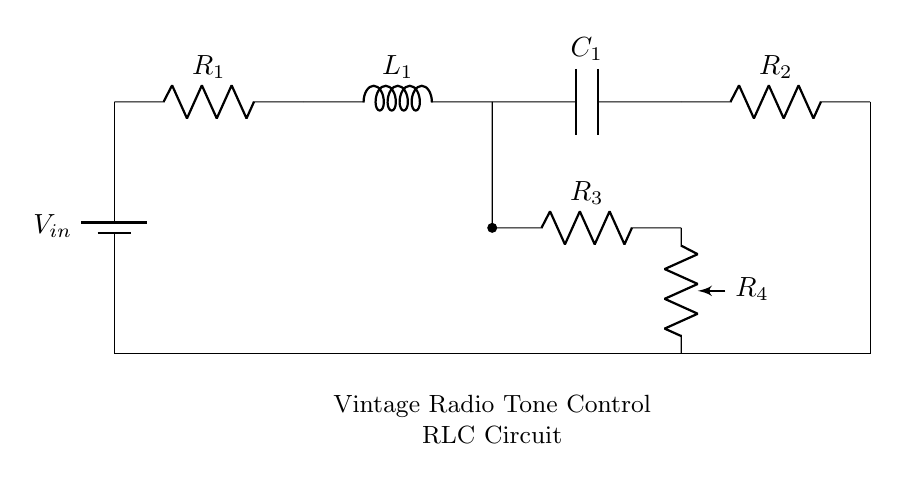What is the input voltage of this circuit? The input voltage is indicated by the battery symbol labeled as V_in in the circuit diagram. It provides the power source to the circuit.
Answer: V_in What type of circuit components are used in this diagram? The circuit consists of resistors, an inductor, and a capacitor, which are essential elements of RLC circuits. This is identifiable through the symbols used in the diagram.
Answer: Resistors, inductor, capacitor What is the resistance of R_1? The resistance value of R_1 is not specified in the diagram, but it is depicted as one of the components connected directly to the voltage source. Therefore, it plays a role in controlling current and voltage in the circuit.
Answer: Not specified How many resistors are present in this circuit? By counting the resistor symbols in the circuit, we find four resistors: R_1, R_2, R_3, and R_4. Thus, the total number of resistors is four.
Answer: Four What happens when the potentiometer R_4 is adjusted? Adjusting the potentiometer R_4 changes the resistance in that branch, affecting the current flow and hence the voltage across the connected components. This adjusts the tone of the audio signal in the vintage radio.
Answer: Changes tone What is the purpose of the inductor L_1 in this circuit? The inductor L_1 serves to store energy in a magnetic field and can provide a reactance that varies with frequency. In tone control circuits, it helps in filtering certain frequencies.
Answer: Frequency filtering What is the relationship between the components in an RLC circuit? In an RLC circuit, resistors, inductors, and capacitors interact to determine the circuit's overall impedance and frequency response. This relationship affects how signals are processed and can be analyzed using complex formulas that involve these components.
Answer: Impedance and frequency response 